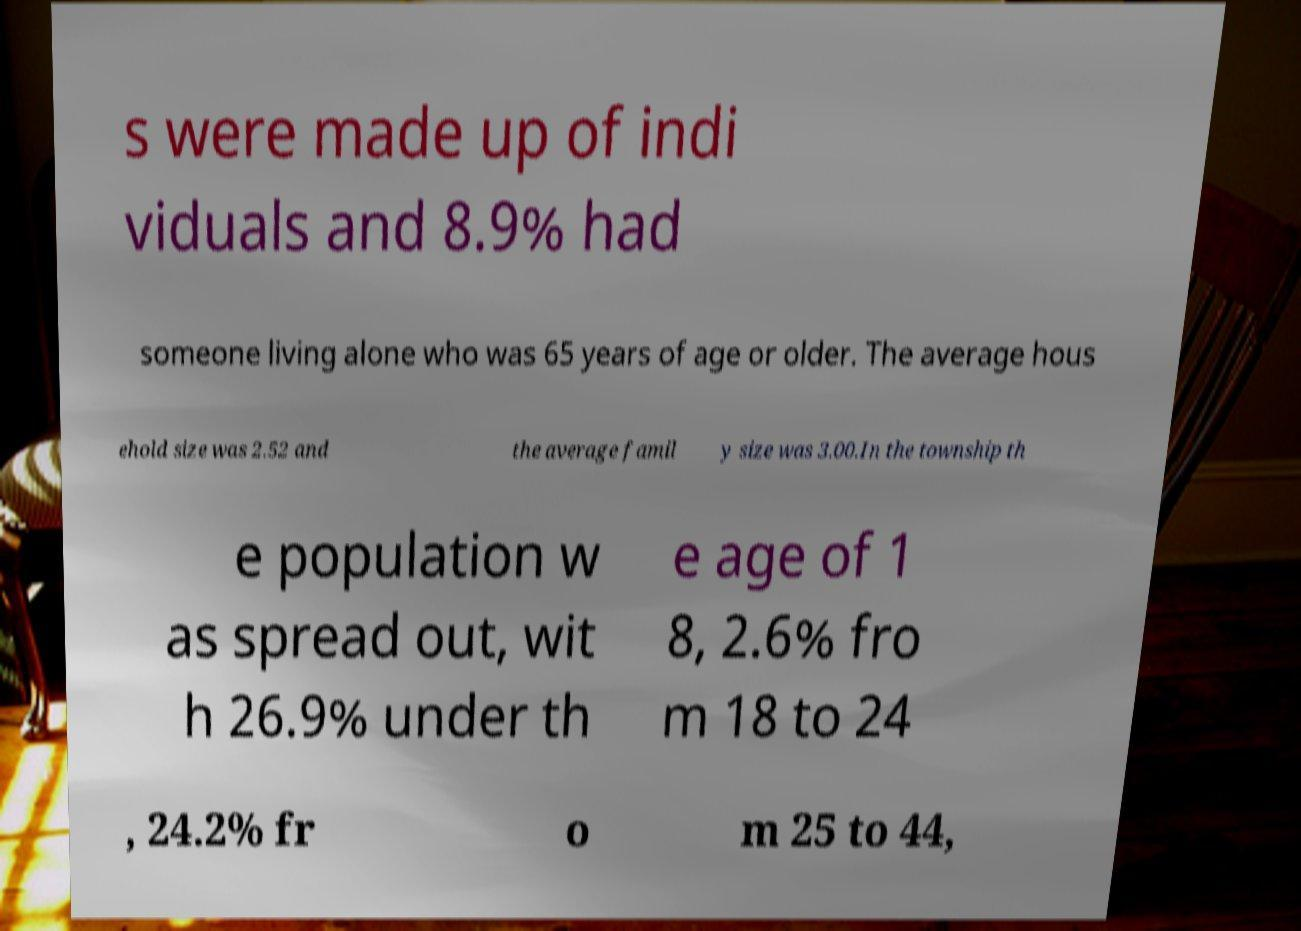Could you assist in decoding the text presented in this image and type it out clearly? s were made up of indi viduals and 8.9% had someone living alone who was 65 years of age or older. The average hous ehold size was 2.52 and the average famil y size was 3.00.In the township th e population w as spread out, wit h 26.9% under th e age of 1 8, 2.6% fro m 18 to 24 , 24.2% fr o m 25 to 44, 